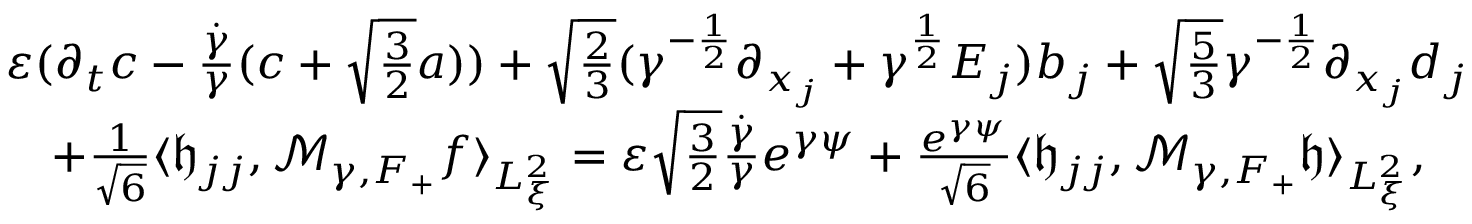<formula> <loc_0><loc_0><loc_500><loc_500>\begin{array} { r l } & { \varepsilon ( \partial _ { t } c - \frac { \dot { \gamma } } { \gamma } ( c + \sqrt { \frac { 3 } { 2 } } a ) ) + \sqrt { \frac { 2 } { 3 } } ( \gamma ^ { - \frac { 1 } { 2 } } \partial _ { x _ { j } } + \gamma ^ { \frac { 1 } { 2 } } E _ { j } ) b _ { j } + \sqrt { \frac { 5 } { 3 } } \gamma ^ { - \frac { 1 } { 2 } } \partial _ { x _ { j } } d _ { j } } \\ & { \quad + \frac { 1 } { \sqrt { 6 } } \langle \mathfrak h _ { j j } , \mathcal { M } _ { \gamma , F _ { + } } f \rangle _ { L _ { \xi } ^ { 2 } } = \varepsilon \sqrt { \frac { 3 } { 2 } } \frac { \dot { \gamma } } { \gamma } e ^ { \gamma \psi } + \frac { e ^ { \gamma \psi } } { \sqrt { 6 } } \langle \mathfrak h _ { j j } , \mathcal { M } _ { \gamma , F _ { + } } \mathfrak h \rangle _ { L _ { \xi } ^ { 2 } } , } \end{array}</formula> 